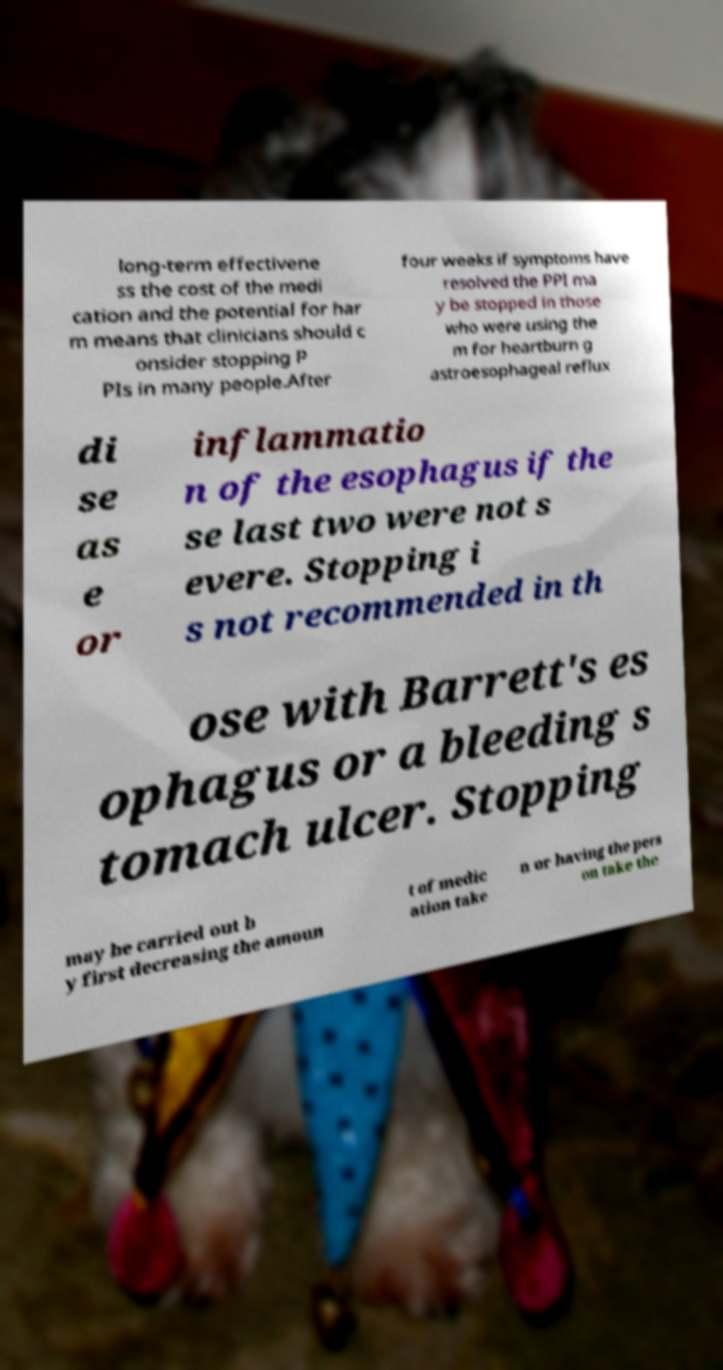Can you accurately transcribe the text from the provided image for me? long-term effectivene ss the cost of the medi cation and the potential for har m means that clinicians should c onsider stopping P PIs in many people.After four weeks if symptoms have resolved the PPI ma y be stopped in those who were using the m for heartburn g astroesophageal reflux di se as e or inflammatio n of the esophagus if the se last two were not s evere. Stopping i s not recommended in th ose with Barrett's es ophagus or a bleeding s tomach ulcer. Stopping may be carried out b y first decreasing the amoun t of medic ation take n or having the pers on take the 